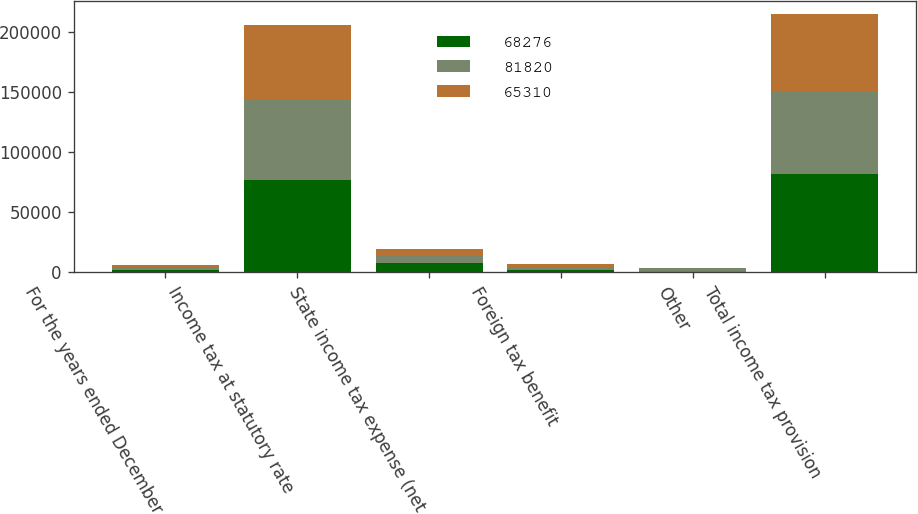Convert chart. <chart><loc_0><loc_0><loc_500><loc_500><stacked_bar_chart><ecel><fcel>For the years ended December<fcel>Income tax at statutory rate<fcel>State income tax expense (net<fcel>Foreign tax benefit<fcel>Other<fcel>Total income tax provision<nl><fcel>68276<fcel>2014<fcel>76820<fcel>7429<fcel>1760<fcel>669<fcel>81820<nl><fcel>81820<fcel>2013<fcel>67063<fcel>6498<fcel>2661<fcel>2624<fcel>68276<nl><fcel>65310<fcel>2012<fcel>61825<fcel>5835<fcel>2560<fcel>210<fcel>65310<nl></chart> 